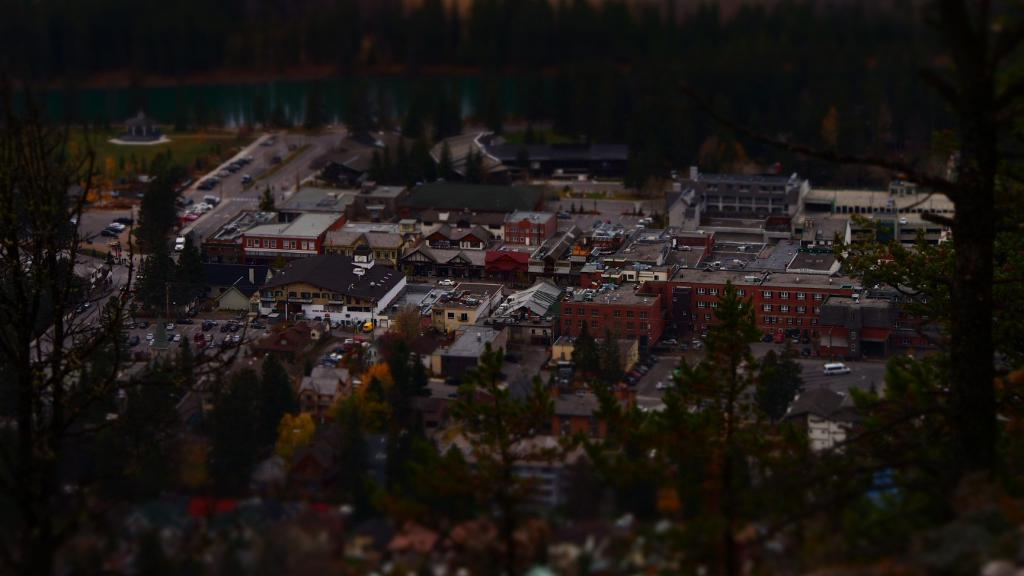What type of structures can be seen in the image? There are buildings in the image. What other natural elements are present in the image? There are trees in the image. What mode of transportation can be seen on the road in the image? There are vehicles on the road in the image. What is visible at the top of the image? There is water visible at the top of the image. Can you tell me the order in which the trees were planted in the image? There is no information about the order in which the trees were planted in the image. How many minutes does it take for the water to flow in the image? The image does not depict the flow of water, so it is impossible to determine the time it takes for the water to flow. 